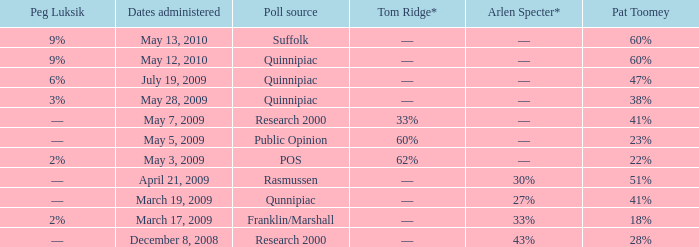Which Poll source has a Peg Luksik of 9%, and Dates administered of may 12, 2010? Quinnipiac. 